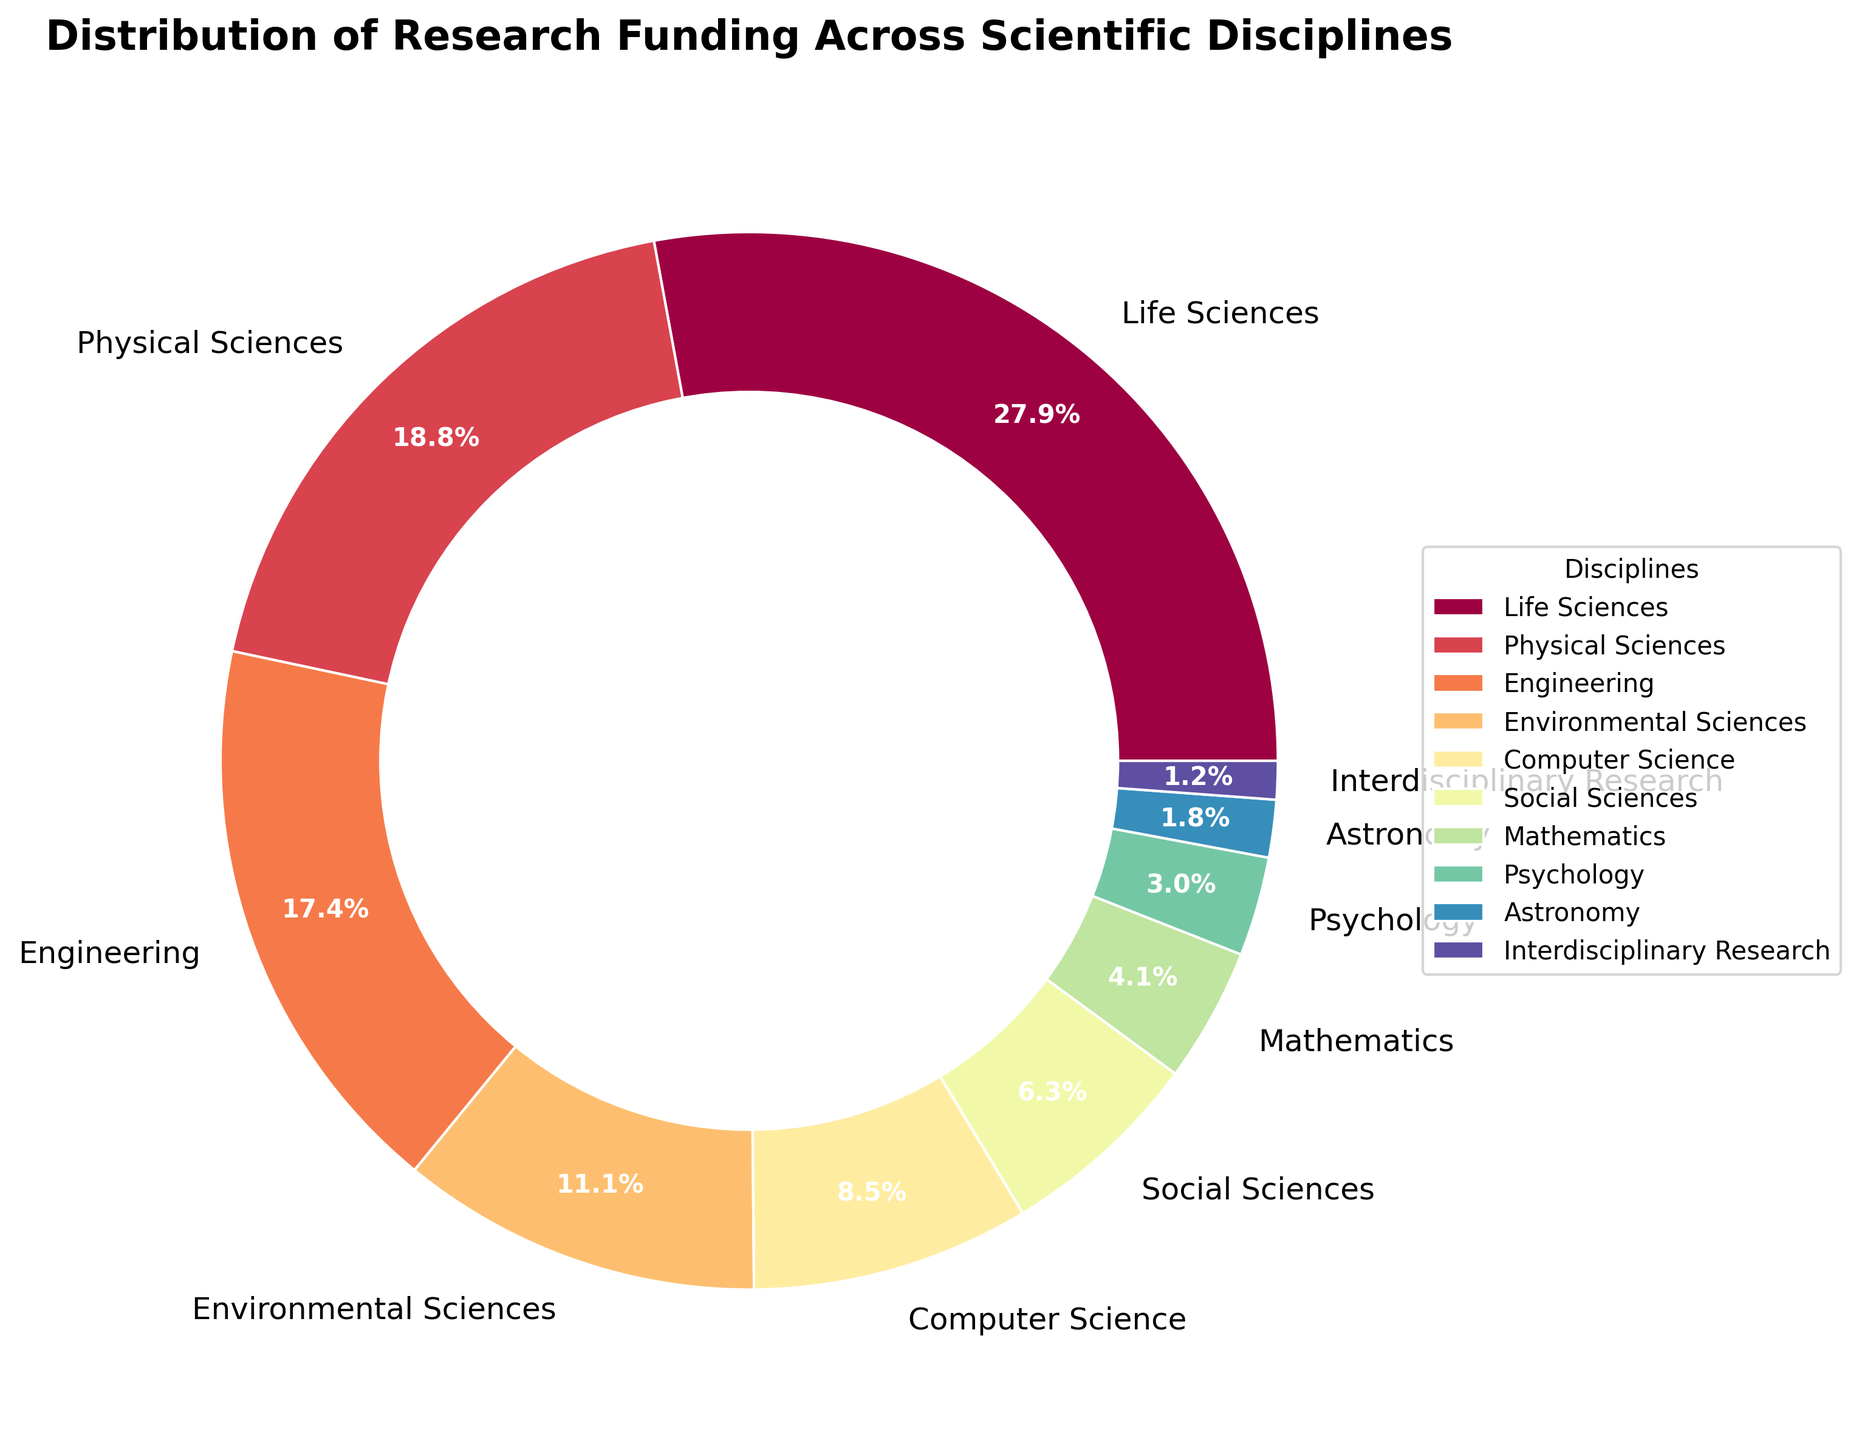Which scientific discipline receives the highest funding percentage? The figure shows that Life Sciences has the largest slice of the pie chart.
Answer: Life Sciences What is the combined funding percentage for Life Sciences and Physical Sciences? The funding percentage for Life Sciences is 28.5% and for Physical Sciences is 19.2%. Adding these together gives 28.5 + 19.2 = 47.7%.
Answer: 47.7% Which disciplines receive less than 5% of the funding? Based on the pie chart, Mathematics, Psychology, Astronomy, and Interdisciplinary Research each have segments representing less than 5%.
Answer: Mathematics, Psychology, Astronomy, Interdisciplinary Research What is the difference in funding percentage between Engineering and Environmental Sciences? Engineering has 17.8% and Environmental Sciences has 11.3%. Subtracting these gives 17.8 - 11.3 = 6.5%.
Answer: 6.5% How does the funding percentage for Computer Science compare to Social Sciences? The funding percentage for Computer Science is 8.7% while for Social Sciences it is 6.4%. Computer Science has a higher percentage than Social Sciences.
Answer: Computer Science has higher funding What is the total funding percentage for the disciplines receiving the least amount of funding (Astronomy and Interdisciplinary Research)? Astronomy receives 1.8% and Interdisciplinary Research receives 1.2%. Adding these together gives 1.8 + 1.2 = 3.0%.
Answer: 3.0% Is the funding percentage for Mathematics closest to that of Psychology or Social Sciences? Mathematics has 4.2%, Psychology has 3.1%, and Social Sciences has 6.4%. The difference between Mathematics and Psychology is 4.2 - 3.1 = 1.1%, and the difference between Mathematics and Social Sciences is 6.4 - 4.2 = 2.2%. Therefore, Mathematics is closer to Psychology in funding percentage.
Answer: Psychology Which two adjacent disciplines in the pie chart have the most similar funding percentages? From the pie chart, Mathematics and Psychology are adjacent with 4.2% and 3.1% respectively. The difference between their funding percentages is 4.2 - 3.1 = 1.1%, which is the smallest difference among adjacent slices.
Answer: Mathematics and Psychology What is the average funding percentage for Social Sciences, Mathematics, and Psychology? The funding percentages are Social Sciences (6.4%), Mathematics (4.2%), and Psychology (3.1%). Their sum is 6.4 + 4.2 + 3.1 = 13.7%. Dividing by 3 gives 13.7 / 3 ≈ 4.57%.
Answer: 4.57% Which slice is visually closest in size to the Physical Sciences slice? Observing the pie chart, the Engineering slice appears closest in size to the Physical Sciences slice.
Answer: Engineering 